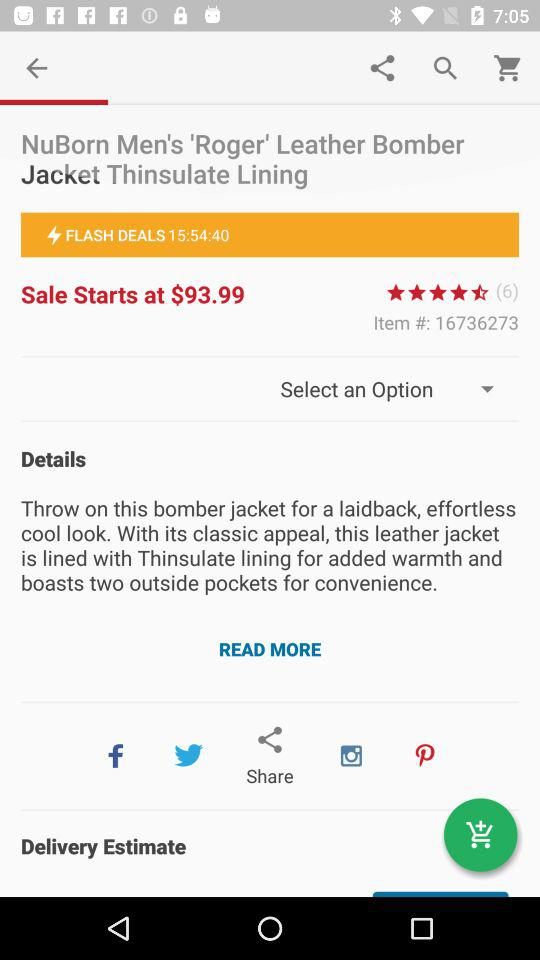What is the price at which the sale starts? The sale starts at $93.99. 